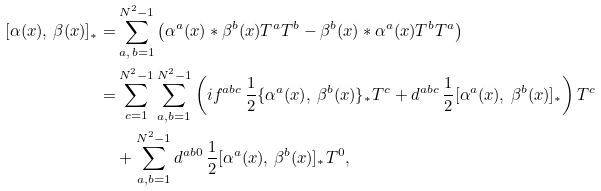Convert formula to latex. <formula><loc_0><loc_0><loc_500><loc_500>[ \alpha ( x ) , \, \beta ( x ) ] _ { \ast } = & \sum _ { a , \, b = 1 } ^ { N ^ { 2 } - 1 } \left ( \alpha ^ { a } ( x ) \ast \beta ^ { b } ( x ) T ^ { a } T ^ { b } - \beta ^ { b } ( x ) \ast \alpha ^ { a } ( x ) T ^ { b } T ^ { a } \right ) \\ = & \sum _ { c = 1 } ^ { N ^ { 2 } - 1 } \sum _ { a , b = 1 } ^ { N ^ { 2 } - 1 } \left ( i f ^ { a b c } \, \frac { 1 } { 2 } \{ \alpha ^ { a } ( x ) , \, \beta ^ { b } ( x ) \} _ { \ast } T ^ { c } + d ^ { a b c } \, \frac { 1 } { 2 } [ \alpha ^ { a } ( x ) , \, \beta ^ { b } ( x ) ] _ { \ast } \right ) T ^ { c } \\ & + \sum _ { a , b = 1 } ^ { N ^ { 2 } - 1 } d ^ { a b 0 } \, \frac { 1 } { 2 } [ \alpha ^ { a } ( x ) , \, \beta ^ { b } ( x ) ] _ { \ast } T ^ { 0 } ,</formula> 